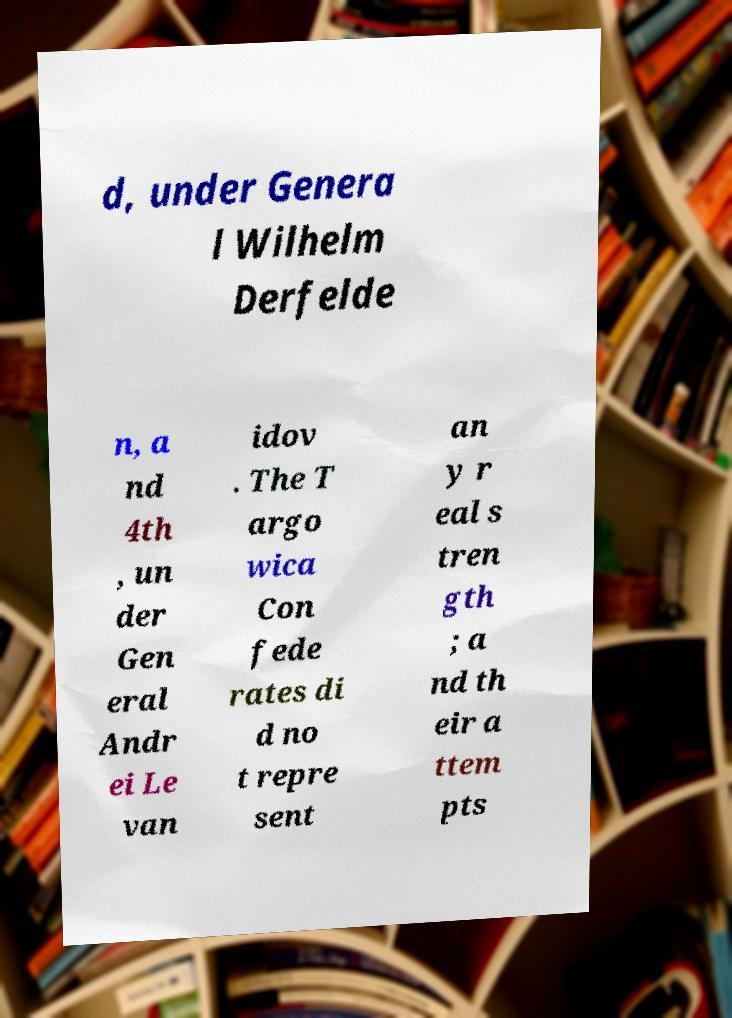For documentation purposes, I need the text within this image transcribed. Could you provide that? d, under Genera l Wilhelm Derfelde n, a nd 4th , un der Gen eral Andr ei Le van idov . The T argo wica Con fede rates di d no t repre sent an y r eal s tren gth ; a nd th eir a ttem pts 